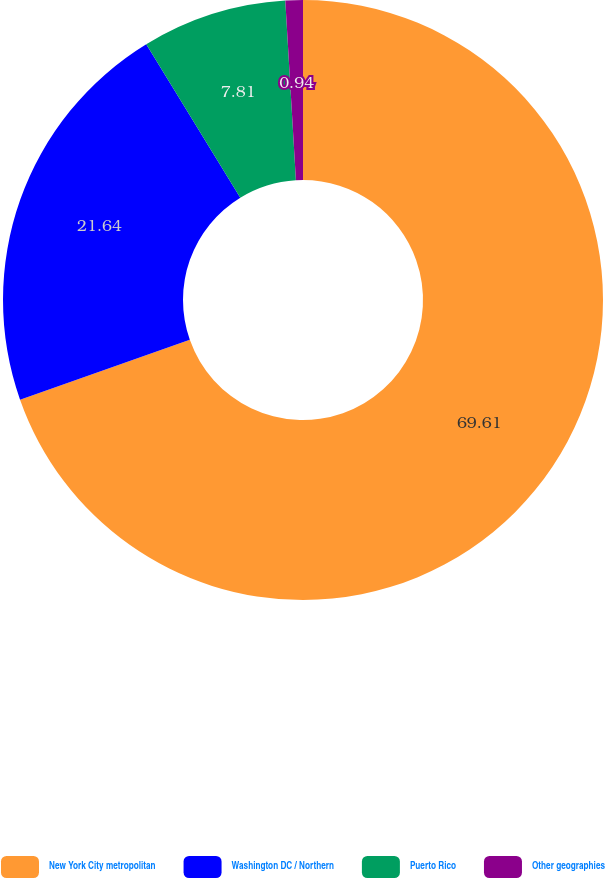Convert chart. <chart><loc_0><loc_0><loc_500><loc_500><pie_chart><fcel>New York City metropolitan<fcel>Washington DC / Northern<fcel>Puerto Rico<fcel>Other geographies<nl><fcel>69.61%<fcel>21.64%<fcel>7.81%<fcel>0.94%<nl></chart> 